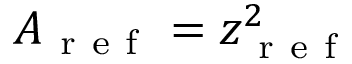Convert formula to latex. <formula><loc_0><loc_0><loc_500><loc_500>A _ { r e f } = z _ { r e f } ^ { 2 }</formula> 